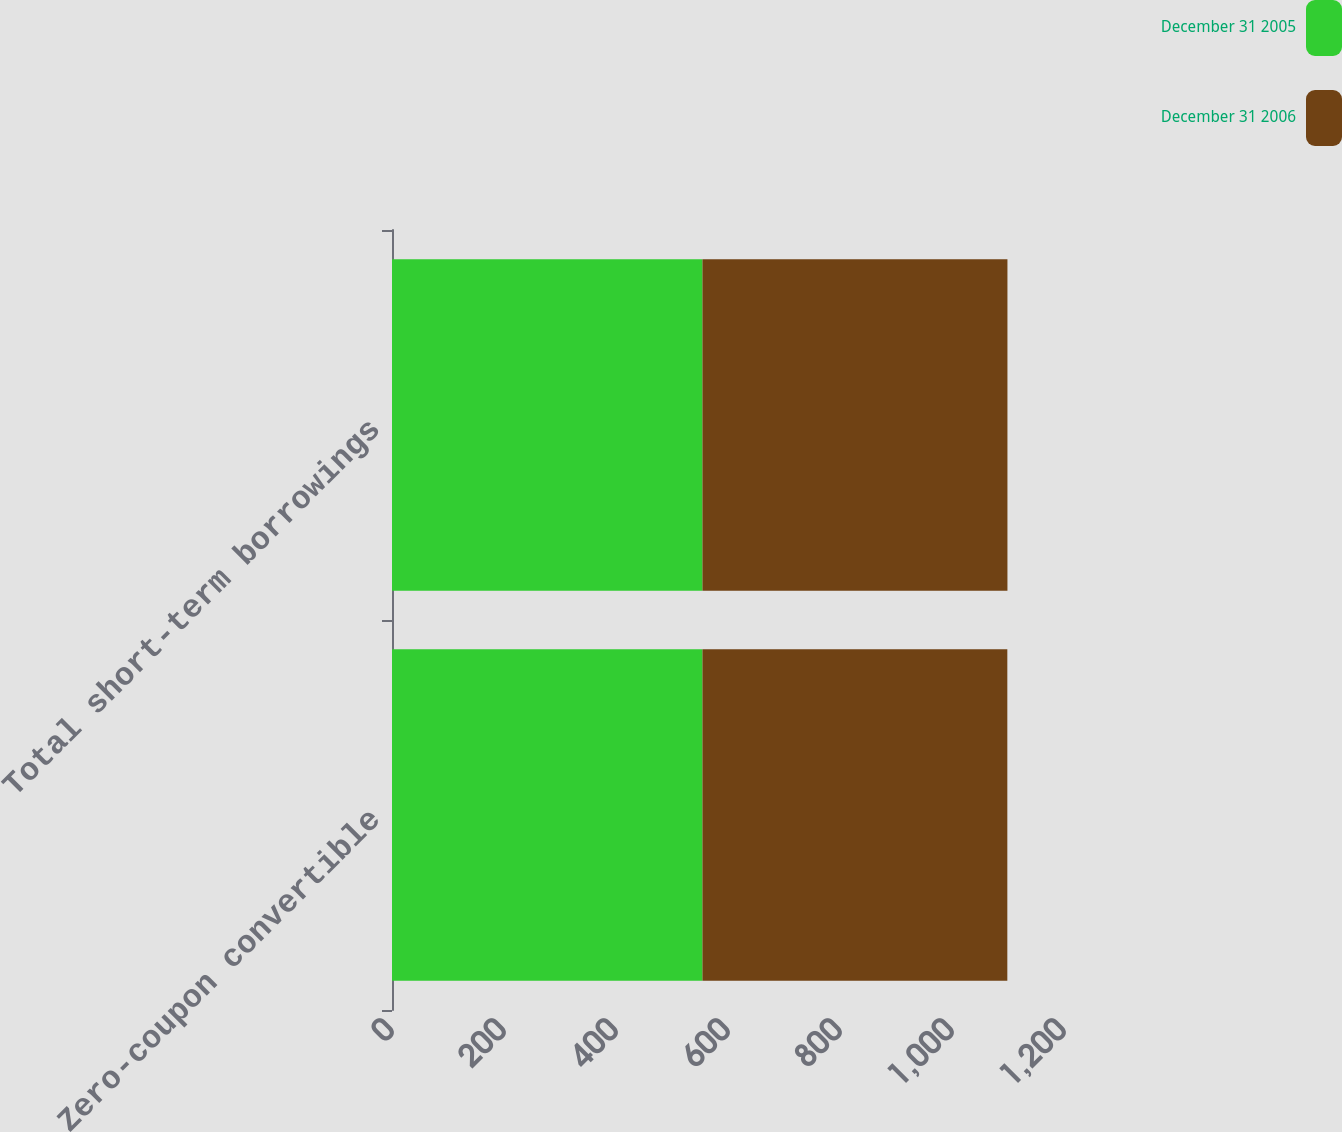Convert chart to OTSL. <chart><loc_0><loc_0><loc_500><loc_500><stacked_bar_chart><ecel><fcel>Zero-coupon convertible<fcel>Total short-term borrowings<nl><fcel>December 31 2005<fcel>554.4<fcel>554.4<nl><fcel>December 31 2006<fcel>544.4<fcel>544.6<nl></chart> 